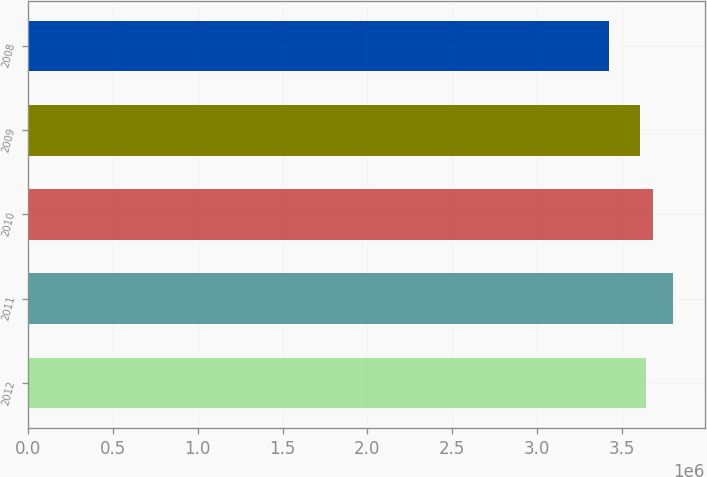Convert chart to OTSL. <chart><loc_0><loc_0><loc_500><loc_500><bar_chart><fcel>2012<fcel>2011<fcel>2010<fcel>2009<fcel>2008<nl><fcel>3.6444e+06<fcel>3.8e+06<fcel>3.6818e+06<fcel>3.607e+06<fcel>3.426e+06<nl></chart> 